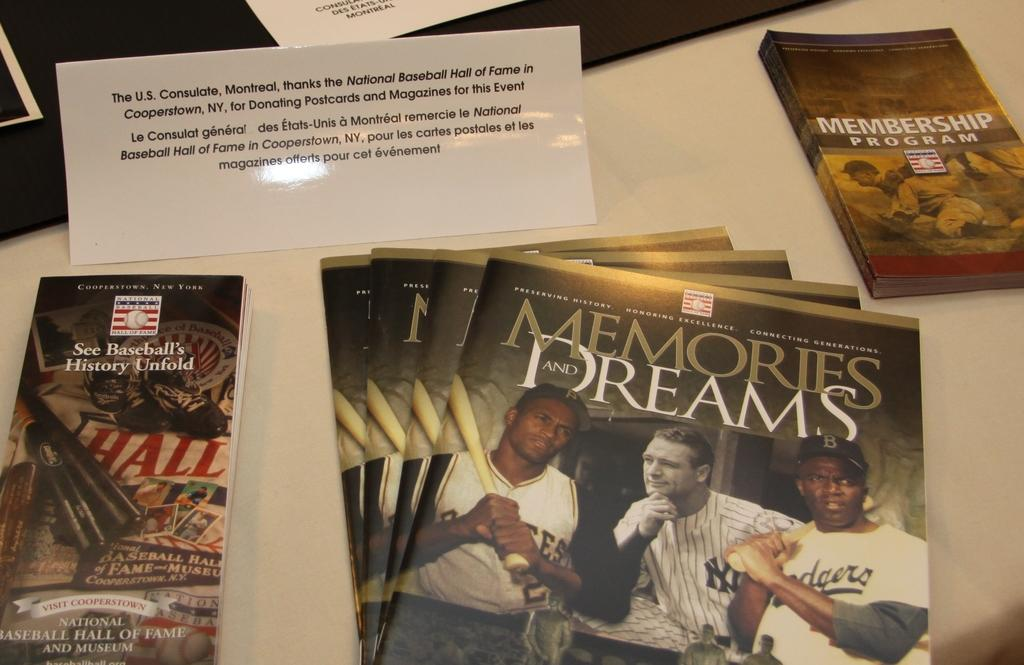What type of reading material is present in the image? There is a magazine, a pamphlet, and a book in the image. What is the color of the surface on which the objects are placed? The objects are on a white surface. How much honey is on the white surface in the image? There is no honey present in the image. What authority figure is depicted in the image? There is no authority figure depicted in the image; it features a magazine, pamphlet, and book on a white surface. 